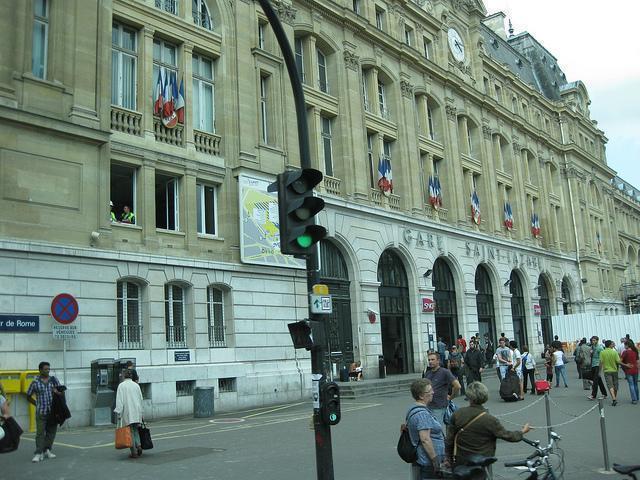What actress was born in this country?
Choose the right answer from the provided options to respond to the question.
Options: Jennifer connelly, adele haenel, margaret qualley, brooke shields. Adele haenel. What country's flag is being flown?
Choose the right answer from the provided options to respond to the question.
Options: France, italy, switzerland, england. France. 